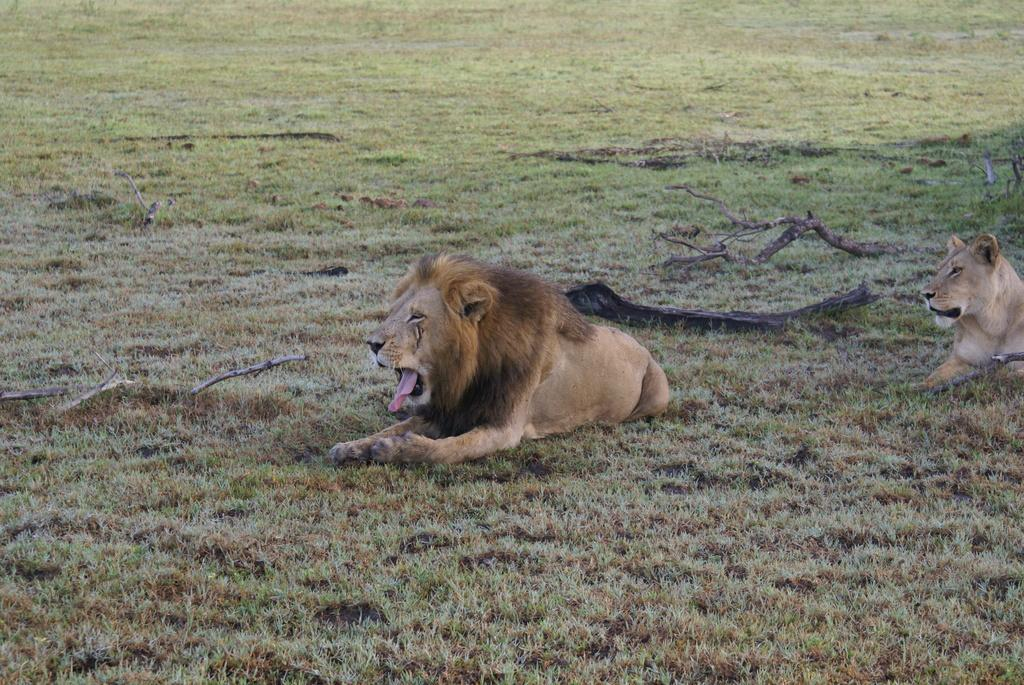What animals can be seen in the image? There is a lion and a tiger in the image. Where are the lion and tiger located in the image? The lion and tiger are sitting on the grass in the image. What else can be seen on the ground in the image? There are sticks on the ground in the image. What type of poison is the lion using to attack the tiger in the image? There is no poison or attack present in the image; the lion and tiger are simply sitting on the grass. What advice is the tiger giving to the lion in the image? There is no conversation or advice-giving present in the image; the lion and tiger are just sitting on the grass. 